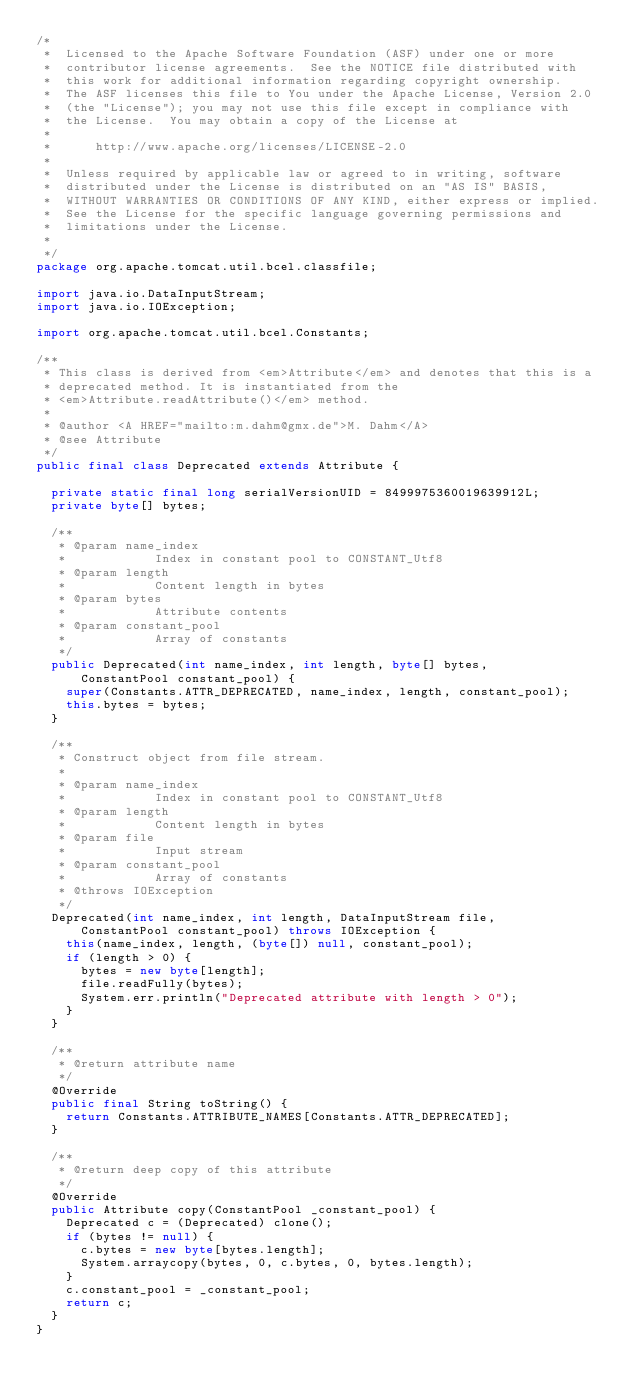Convert code to text. <code><loc_0><loc_0><loc_500><loc_500><_Java_>/*
 *  Licensed to the Apache Software Foundation (ASF) under one or more
 *  contributor license agreements.  See the NOTICE file distributed with
 *  this work for additional information regarding copyright ownership.
 *  The ASF licenses this file to You under the Apache License, Version 2.0
 *  (the "License"); you may not use this file except in compliance with
 *  the License.  You may obtain a copy of the License at
 *
 *      http://www.apache.org/licenses/LICENSE-2.0
 *
 *  Unless required by applicable law or agreed to in writing, software
 *  distributed under the License is distributed on an "AS IS" BASIS,
 *  WITHOUT WARRANTIES OR CONDITIONS OF ANY KIND, either express or implied.
 *  See the License for the specific language governing permissions and
 *  limitations under the License.
 *
 */
package org.apache.tomcat.util.bcel.classfile;

import java.io.DataInputStream;
import java.io.IOException;

import org.apache.tomcat.util.bcel.Constants;

/**
 * This class is derived from <em>Attribute</em> and denotes that this is a
 * deprecated method. It is instantiated from the
 * <em>Attribute.readAttribute()</em> method.
 *
 * @author <A HREF="mailto:m.dahm@gmx.de">M. Dahm</A>
 * @see Attribute
 */
public final class Deprecated extends Attribute {

	private static final long serialVersionUID = 8499975360019639912L;
	private byte[] bytes;

	/**
	 * @param name_index
	 *            Index in constant pool to CONSTANT_Utf8
	 * @param length
	 *            Content length in bytes
	 * @param bytes
	 *            Attribute contents
	 * @param constant_pool
	 *            Array of constants
	 */
	public Deprecated(int name_index, int length, byte[] bytes,
			ConstantPool constant_pool) {
		super(Constants.ATTR_DEPRECATED, name_index, length, constant_pool);
		this.bytes = bytes;
	}

	/**
	 * Construct object from file stream.
	 * 
	 * @param name_index
	 *            Index in constant pool to CONSTANT_Utf8
	 * @param length
	 *            Content length in bytes
	 * @param file
	 *            Input stream
	 * @param constant_pool
	 *            Array of constants
	 * @throws IOException
	 */
	Deprecated(int name_index, int length, DataInputStream file,
			ConstantPool constant_pool) throws IOException {
		this(name_index, length, (byte[]) null, constant_pool);
		if (length > 0) {
			bytes = new byte[length];
			file.readFully(bytes);
			System.err.println("Deprecated attribute with length > 0");
		}
	}

	/**
	 * @return attribute name
	 */
	@Override
	public final String toString() {
		return Constants.ATTRIBUTE_NAMES[Constants.ATTR_DEPRECATED];
	}

	/**
	 * @return deep copy of this attribute
	 */
	@Override
	public Attribute copy(ConstantPool _constant_pool) {
		Deprecated c = (Deprecated) clone();
		if (bytes != null) {
			c.bytes = new byte[bytes.length];
			System.arraycopy(bytes, 0, c.bytes, 0, bytes.length);
		}
		c.constant_pool = _constant_pool;
		return c;
	}
}
</code> 